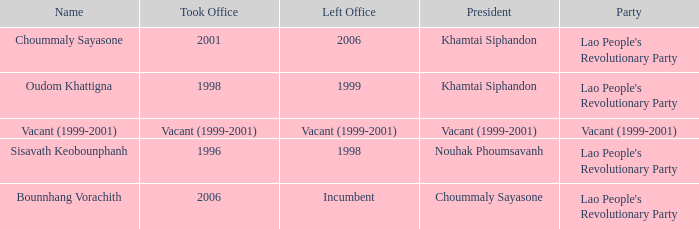What is Left Office, when Took Office is 1998? 1999.0. 